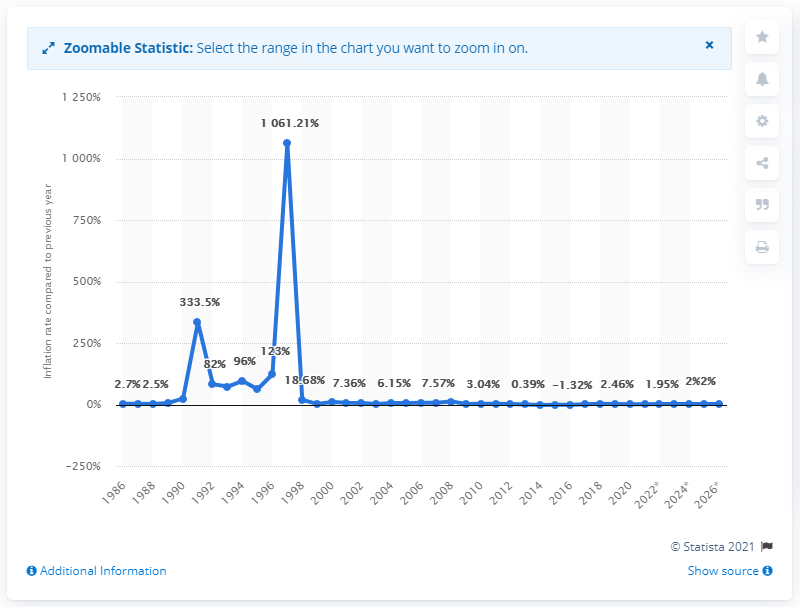Identify some key points in this picture. In 2020, the inflation rate in Bulgaria was 1.22%. 